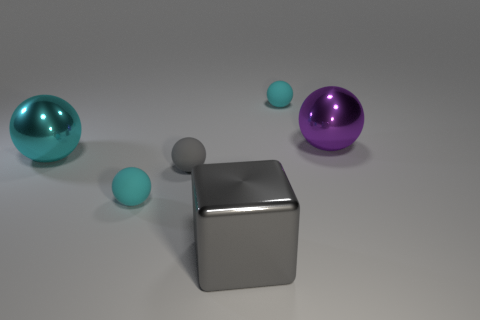What number of other things are there of the same material as the tiny gray sphere
Ensure brevity in your answer.  2. Does the big cyan sphere have the same material as the gray block?
Your response must be concise. Yes. What number of other objects are the same size as the gray metal object?
Your response must be concise. 2. What is the size of the cyan matte ball behind the big metal thing that is to the left of the big gray cube?
Give a very brief answer. Small. What is the color of the tiny ball behind the big thing on the left side of the gray thing that is on the left side of the big metallic cube?
Make the answer very short. Cyan. There is a thing that is both in front of the small gray ball and behind the big gray metal cube; how big is it?
Ensure brevity in your answer.  Small. What number of other things are the same shape as the large cyan metallic object?
Your response must be concise. 4. What number of balls are either big metallic things or gray objects?
Make the answer very short. 3. Are there any large balls to the right of the tiny cyan object left of the rubber sphere that is behind the purple object?
Keep it short and to the point. Yes. What is the color of the other metal thing that is the same shape as the large cyan metallic thing?
Keep it short and to the point. Purple. 